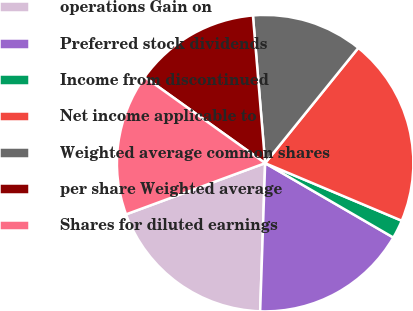Convert chart to OTSL. <chart><loc_0><loc_0><loc_500><loc_500><pie_chart><fcel>operations Gain on<fcel>Preferred stock dividends<fcel>Income from discontinued<fcel>Net income applicable to<fcel>Weighted average common shares<fcel>per share Weighted average<fcel>Shares for diluted earnings<nl><fcel>18.85%<fcel>17.17%<fcel>2.02%<fcel>20.53%<fcel>12.13%<fcel>13.81%<fcel>15.49%<nl></chart> 